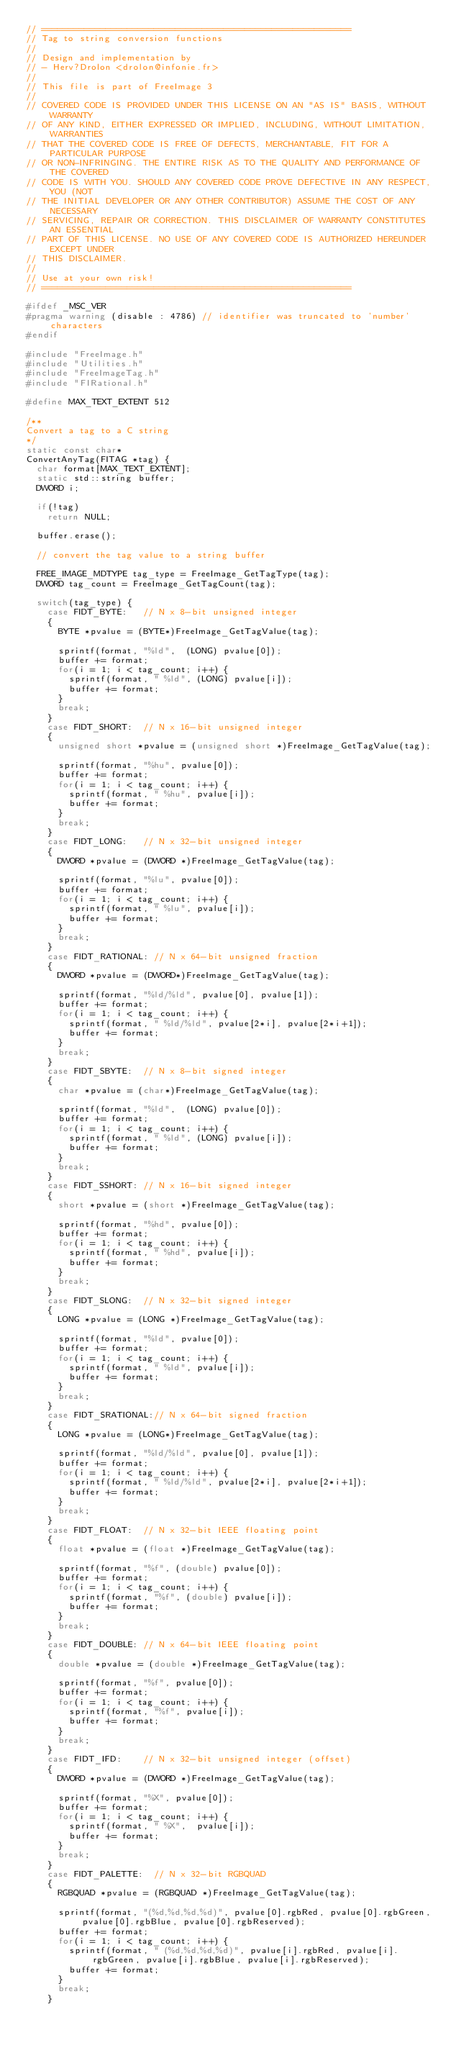<code> <loc_0><loc_0><loc_500><loc_500><_C++_>// ==========================================================
// Tag to string conversion functions
//
// Design and implementation by
// - Herv?Drolon <drolon@infonie.fr>
//
// This file is part of FreeImage 3
//
// COVERED CODE IS PROVIDED UNDER THIS LICENSE ON AN "AS IS" BASIS, WITHOUT WARRANTY
// OF ANY KIND, EITHER EXPRESSED OR IMPLIED, INCLUDING, WITHOUT LIMITATION, WARRANTIES
// THAT THE COVERED CODE IS FREE OF DEFECTS, MERCHANTABLE, FIT FOR A PARTICULAR PURPOSE
// OR NON-INFRINGING. THE ENTIRE RISK AS TO THE QUALITY AND PERFORMANCE OF THE COVERED
// CODE IS WITH YOU. SHOULD ANY COVERED CODE PROVE DEFECTIVE IN ANY RESPECT, YOU (NOT
// THE INITIAL DEVELOPER OR ANY OTHER CONTRIBUTOR) ASSUME THE COST OF ANY NECESSARY
// SERVICING, REPAIR OR CORRECTION. THIS DISCLAIMER OF WARRANTY CONSTITUTES AN ESSENTIAL
// PART OF THIS LICENSE. NO USE OF ANY COVERED CODE IS AUTHORIZED HEREUNDER EXCEPT UNDER
// THIS DISCLAIMER.
//
// Use at your own risk!
// ==========================================================

#ifdef _MSC_VER
#pragma warning (disable : 4786) // identifier was truncated to 'number' characters
#endif

#include "FreeImage.h"
#include "Utilities.h"
#include "FreeImageTag.h"
#include "FIRational.h"

#define MAX_TEXT_EXTENT	512

/**
Convert a tag to a C string
*/
static const char*
ConvertAnyTag(FITAG *tag) {
	char format[MAX_TEXT_EXTENT];
	static std::string buffer;
	DWORD i;

	if(!tag)
		return NULL;

	buffer.erase();

	// convert the tag value to a string buffer

	FREE_IMAGE_MDTYPE tag_type = FreeImage_GetTagType(tag);
	DWORD tag_count = FreeImage_GetTagCount(tag);

	switch(tag_type) {
		case FIDT_BYTE:		// N x 8-bit unsigned integer
		{
			BYTE *pvalue = (BYTE*)FreeImage_GetTagValue(tag);

			sprintf(format, "%ld",	(LONG) pvalue[0]);
			buffer += format;
			for(i = 1; i < tag_count; i++) {
				sprintf(format, " %ld",	(LONG) pvalue[i]);
				buffer += format;
			}
			break;
		}
		case FIDT_SHORT:	// N x 16-bit unsigned integer
		{
			unsigned short *pvalue = (unsigned short *)FreeImage_GetTagValue(tag);

			sprintf(format, "%hu", pvalue[0]);
			buffer += format;
			for(i = 1; i < tag_count; i++) {
				sprintf(format, " %hu",	pvalue[i]);
				buffer += format;
			}
			break;
		}
		case FIDT_LONG:		// N x 32-bit unsigned integer
		{
			DWORD *pvalue = (DWORD *)FreeImage_GetTagValue(tag);

			sprintf(format, "%lu", pvalue[0]);
			buffer += format;
			for(i = 1; i < tag_count; i++) {
				sprintf(format, " %lu",	pvalue[i]);
				buffer += format;
			}
			break;
		}
		case FIDT_RATIONAL: // N x 64-bit unsigned fraction
		{
			DWORD *pvalue = (DWORD*)FreeImage_GetTagValue(tag);

			sprintf(format, "%ld/%ld", pvalue[0], pvalue[1]);
			buffer += format;
			for(i = 1; i < tag_count; i++) {
				sprintf(format, " %ld/%ld", pvalue[2*i], pvalue[2*i+1]);
				buffer += format;
			}
			break;
		}
		case FIDT_SBYTE:	// N x 8-bit signed integer
		{
			char *pvalue = (char*)FreeImage_GetTagValue(tag);

			sprintf(format, "%ld",	(LONG) pvalue[0]);
			buffer += format;
			for(i = 1; i < tag_count; i++) {
				sprintf(format, " %ld",	(LONG) pvalue[i]);
				buffer += format;
			}
			break;
		}
		case FIDT_SSHORT:	// N x 16-bit signed integer
		{
			short *pvalue = (short *)FreeImage_GetTagValue(tag);

			sprintf(format, "%hd", pvalue[0]);
			buffer += format;
			for(i = 1; i < tag_count; i++) {
				sprintf(format, " %hd",	pvalue[i]);
				buffer += format;
			}
			break;
		}
		case FIDT_SLONG:	// N x 32-bit signed integer
		{
			LONG *pvalue = (LONG *)FreeImage_GetTagValue(tag);

			sprintf(format, "%ld", pvalue[0]);
			buffer += format;
			for(i = 1; i < tag_count; i++) {
				sprintf(format, " %ld",	pvalue[i]);
				buffer += format;
			}
			break;
		}
		case FIDT_SRATIONAL:// N x 64-bit signed fraction
		{
			LONG *pvalue = (LONG*)FreeImage_GetTagValue(tag);

			sprintf(format, "%ld/%ld", pvalue[0], pvalue[1]);
			buffer += format;
			for(i = 1; i < tag_count; i++) {
				sprintf(format, " %ld/%ld", pvalue[2*i], pvalue[2*i+1]);
				buffer += format;
			}
			break;
		}
		case FIDT_FLOAT:	// N x 32-bit IEEE floating point
		{
			float *pvalue = (float *)FreeImage_GetTagValue(tag);

			sprintf(format, "%f", (double) pvalue[0]);
			buffer += format;
			for(i = 1; i < tag_count; i++) {
				sprintf(format, "%f", (double) pvalue[i]);
				buffer += format;
			}
			break;
		}
		case FIDT_DOUBLE:	// N x 64-bit IEEE floating point
		{
			double *pvalue = (double *)FreeImage_GetTagValue(tag);

			sprintf(format, "%f", pvalue[0]);
			buffer += format;
			for(i = 1; i < tag_count; i++) {
				sprintf(format, "%f", pvalue[i]);
				buffer += format;
			}
			break;
		}
		case FIDT_IFD:		// N x 32-bit unsigned integer (offset)
		{
			DWORD *pvalue = (DWORD *)FreeImage_GetTagValue(tag);

			sprintf(format, "%X", pvalue[0]);
			buffer += format;
			for(i = 1; i < tag_count; i++) {
				sprintf(format, " %X",	pvalue[i]);
				buffer += format;
			}
			break;
		}
		case FIDT_PALETTE:	// N x 32-bit RGBQUAD
		{
			RGBQUAD *pvalue = (RGBQUAD *)FreeImage_GetTagValue(tag);

			sprintf(format, "(%d,%d,%d,%d)", pvalue[0].rgbRed, pvalue[0].rgbGreen, pvalue[0].rgbBlue, pvalue[0].rgbReserved);
			buffer += format;
			for(i = 1; i < tag_count; i++) {
				sprintf(format, " (%d,%d,%d,%d)", pvalue[i].rgbRed, pvalue[i].rgbGreen, pvalue[i].rgbBlue, pvalue[i].rgbReserved);
				buffer += format;
			}
			break;
		}
</code> 